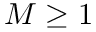<formula> <loc_0><loc_0><loc_500><loc_500>M \geq 1</formula> 